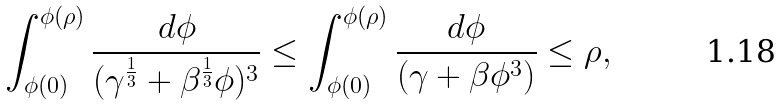<formula> <loc_0><loc_0><loc_500><loc_500>\int _ { \phi ( 0 ) } ^ { \phi ( \rho ) } \frac { d \phi } { ( \gamma ^ { \frac { 1 } { 3 } } + \beta ^ { \frac { 1 } { 3 } } \phi ) ^ { 3 } } \leq \int _ { \phi ( 0 ) } ^ { \phi ( \rho ) } \frac { d \phi } { ( \gamma + \beta \phi ^ { 3 } ) } \leq \rho ,</formula> 